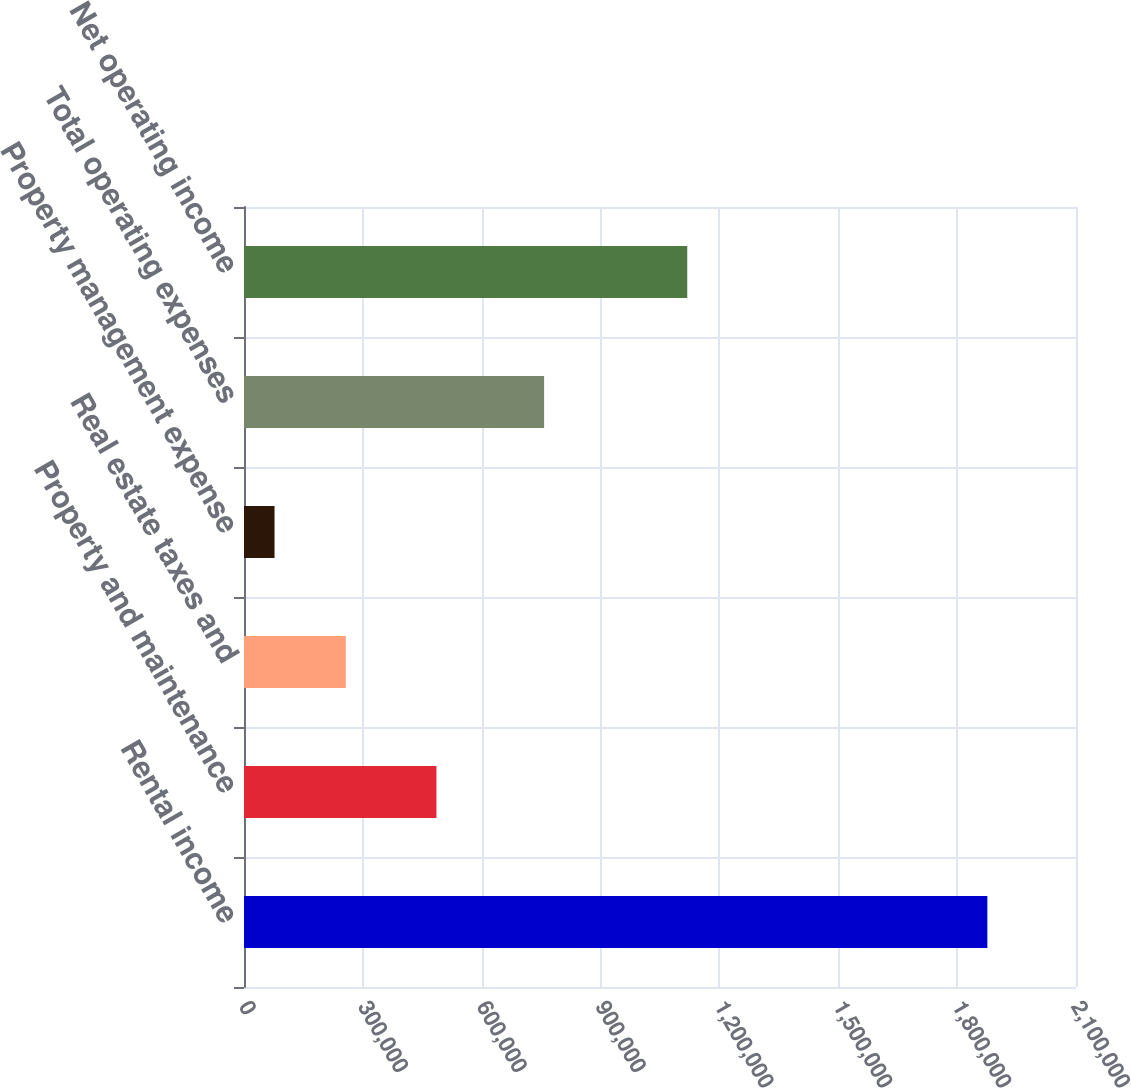Convert chart. <chart><loc_0><loc_0><loc_500><loc_500><bar_chart><fcel>Rental income<fcel>Property and maintenance<fcel>Real estate taxes and<fcel>Property management expense<fcel>Total operating expenses<fcel>Net operating income<nl><fcel>1.87627e+06<fcel>485754<fcel>256984<fcel>77063<fcel>757488<fcel>1.11878e+06<nl></chart> 